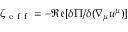<formula> <loc_0><loc_0><loc_500><loc_500>\zeta _ { e f f } = - \mathfrak { R e } [ \delta \Pi / \delta ( \nabla _ { \mu } u ^ { \mu } ) ]</formula> 